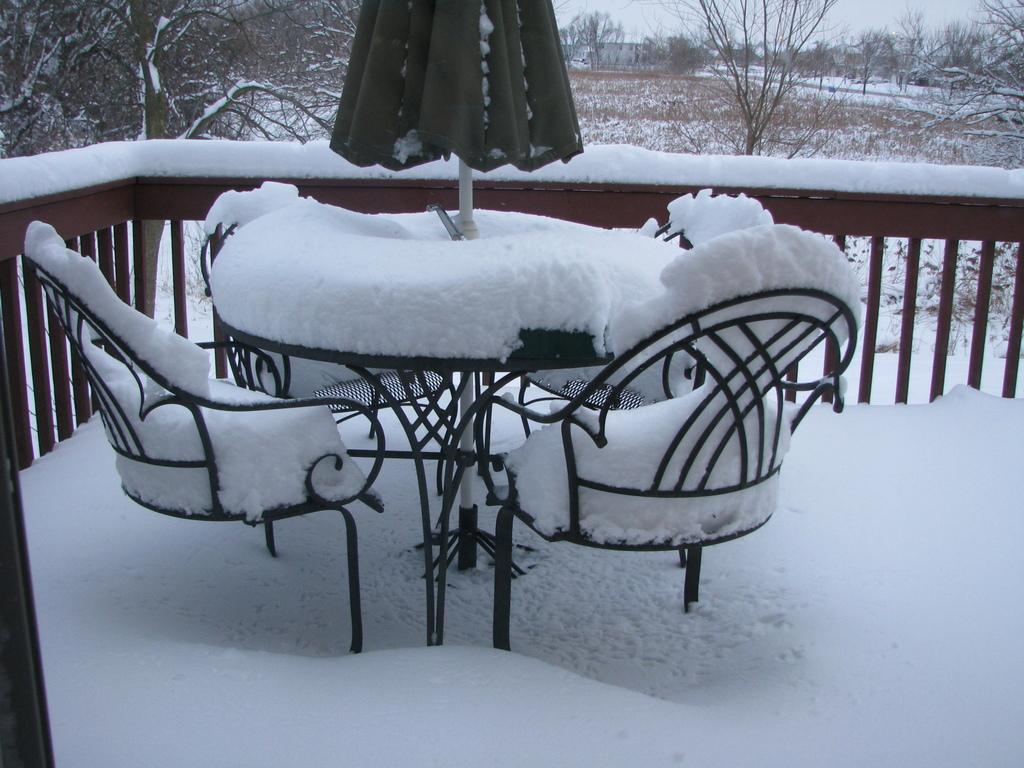What type of outdoor structure is present in the image? There is a deck in the image. What furniture is on the deck? There is a table and chairs on the deck. What is the weather like in the image? There is snow visible in the image, indicating a cold or wintry weather. What can be seen in the background of the image? There are trees, buildings, and the sky visible in the background of the image. What might be used for shade on the deck? There is a parasol in the image, which could be used for shade. What type of cheese is being served on the table in the image? There is no cheese present in the image; the table has a parasol on it. How does the person in the image feel about the hot weather? There is no person present in the image, and the weather is cold due to the snow. 